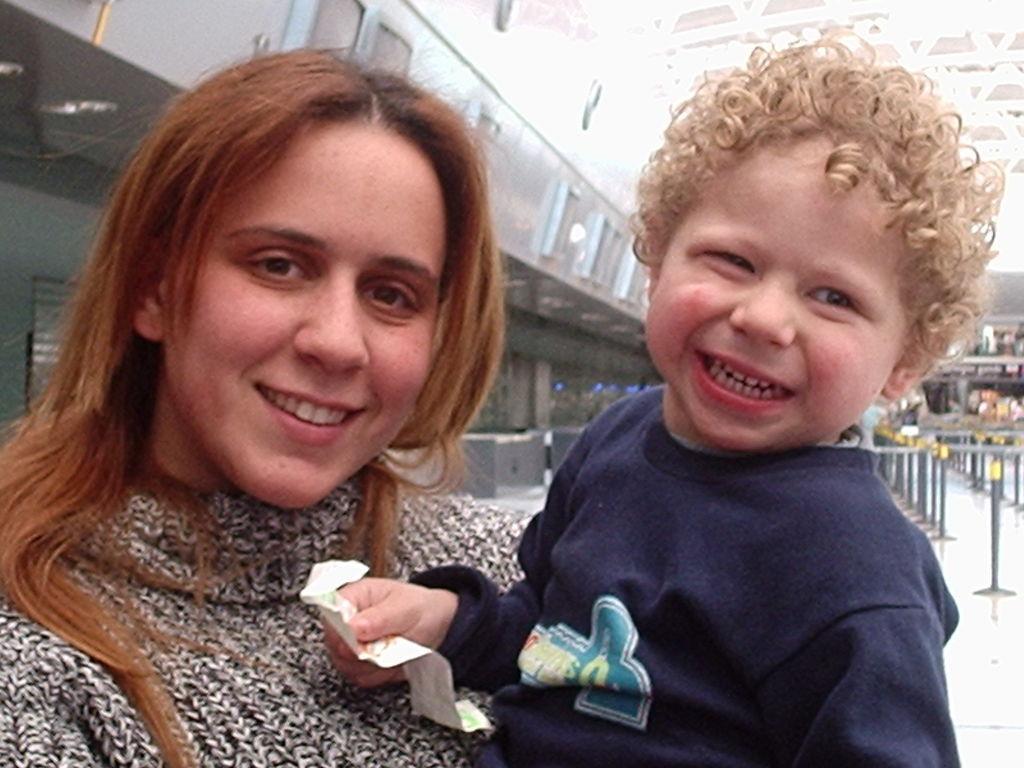How would you summarize this image in a sentence or two? In this picture we can see a woman and a kid here, the kid is holding a paper, in the background there is a building. 